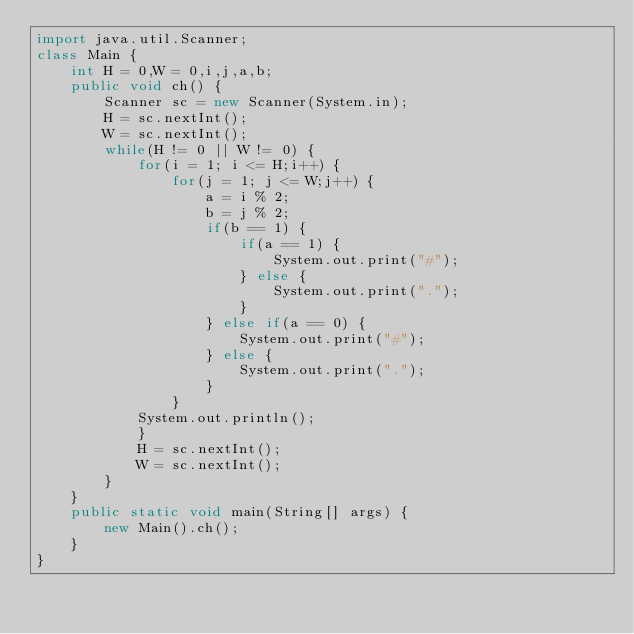<code> <loc_0><loc_0><loc_500><loc_500><_Java_>import java.util.Scanner;
class Main {
	int H = 0,W = 0,i,j,a,b;
	public void ch() {
		Scanner sc = new Scanner(System.in);
		H = sc.nextInt();
		W = sc.nextInt();
		while(H != 0 || W != 0) {
			for(i = 1; i <= H;i++) {
				for(j = 1; j <= W;j++) {
					a = i % 2;
					b = j % 2;
					if(b == 1) {
						if(a == 1) {
							System.out.print("#");
						} else {
							System.out.print(".");
						}
					} else if(a == 0) {
						System.out.print("#");
					} else {
						System.out.print(".");
					}
				}
			System.out.println();
			}
			H = sc.nextInt();
			W = sc.nextInt();
		}
	}
	public static void main(String[] args) {
		new Main().ch();
	}
}</code> 